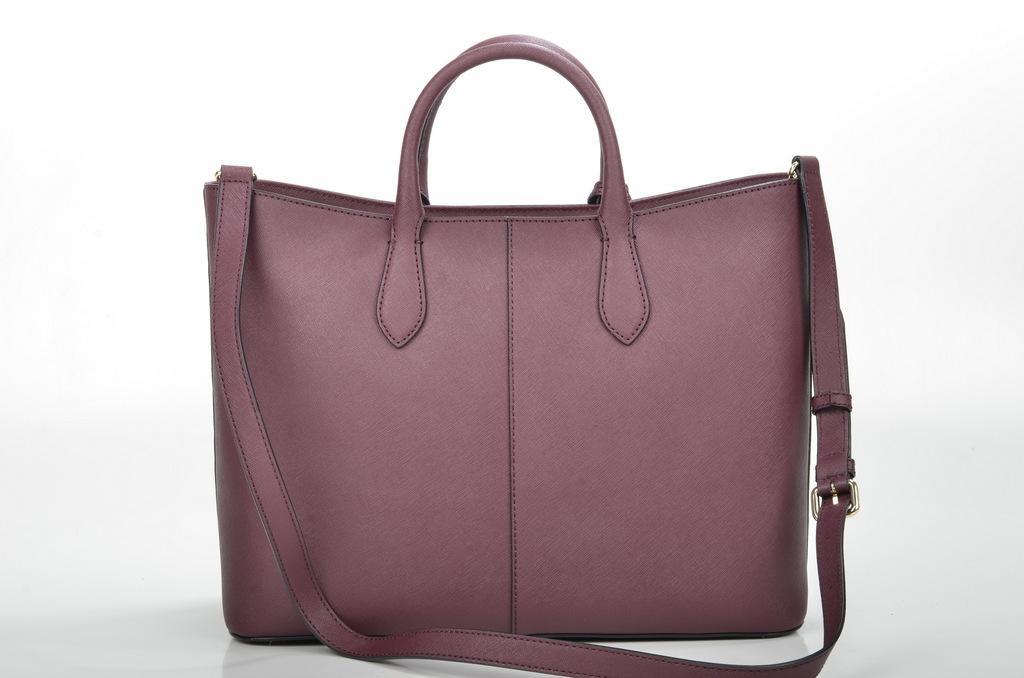In one or two sentences, can you explain what this image depicts? In this image i can see a bag. 